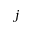Convert formula to latex. <formula><loc_0><loc_0><loc_500><loc_500>j</formula> 